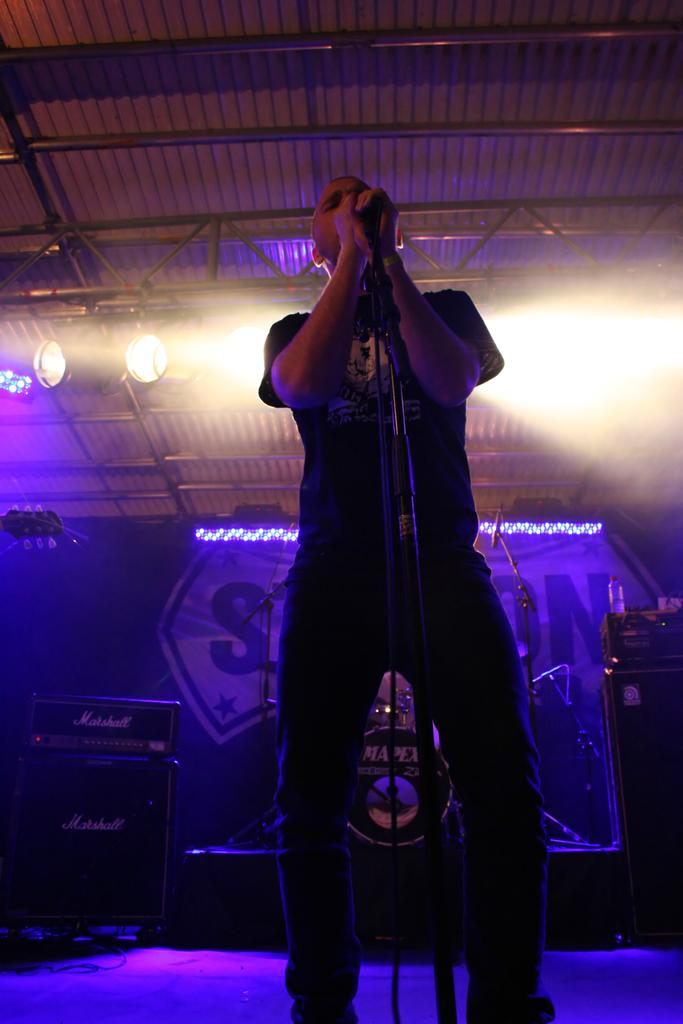What is the person in the image doing? The person is standing in the image and holding a microphone. What other equipment can be seen in the image? There are speakers and focus lights visible in the image. What type of structure is present in the image? A lighting truss is visible in the image. Is there any signage or advertising in the image? Yes, there is a banner in the image. How many leaves can be seen falling from the sky in the image? There are no leaves visible in the image, as it does not depict any outdoor or natural scenes. 